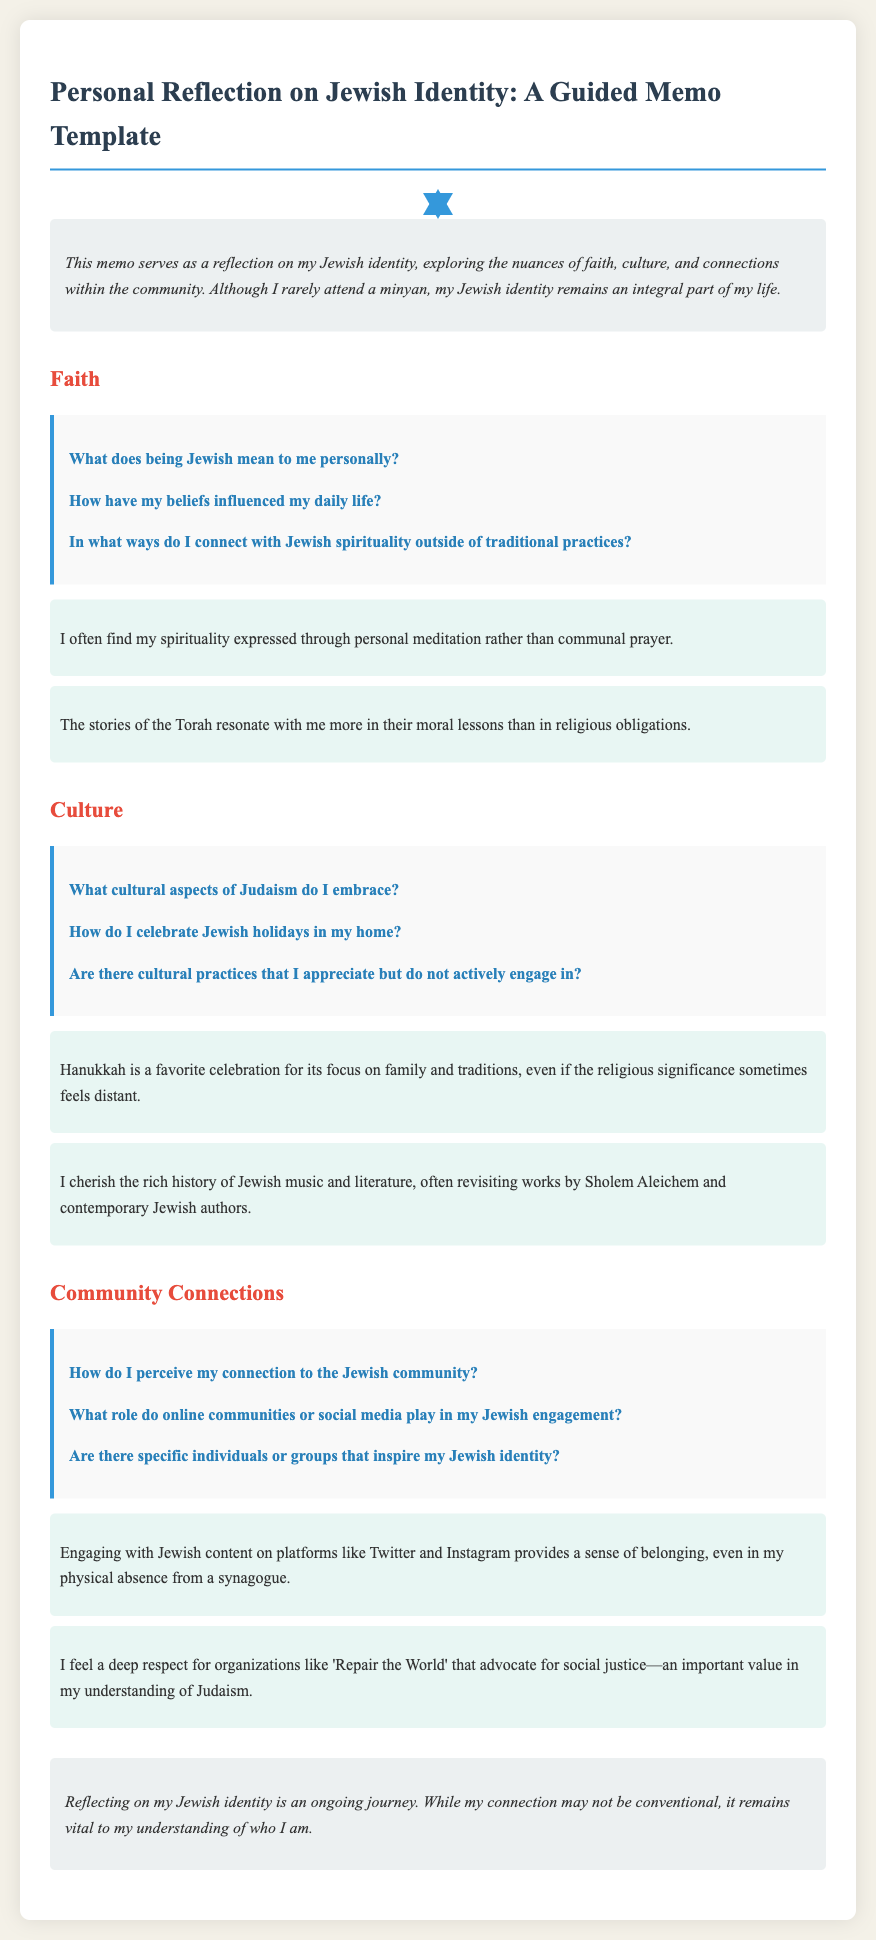What is the title of the memo? The title of the memo is provided in the document heading.
Answer: Personal Reflection on Jewish Identity: A Guided Memo Template What section discusses belief and spirituality? The section specifically addressing belief and spirituality is labeled in the document.
Answer: Faith How do the reflections express connection to spirituality? The reflections indicate how the individual connects with spirituality through personal practices.
Answer: Personal meditation Which holiday is mentioned as a favorite? The document identifies specific holidays celebrated or cherished by the author.
Answer: Hanukkah What organization is respected for its social justice efforts? The document points to an organization that aligns with the author's values regarding social justice in Judaism.
Answer: Repair the World What platforms are mentioned for Jewish engagement? The memo describes types of platforms that facilitate the author's connection to the Jewish community.
Answer: Twitter and Instagram What is emphasized in the conclusion about Jewish identity? The conclusion summarizes the ongoing journey related to Jewish identity as expressed in the document.
Answer: Ongoing journey What cultural element does the author appreciate? The memo highlights aspects of culture that the author cherishes in relation to their Jewish identity.
Answer: Jewish music and literature 